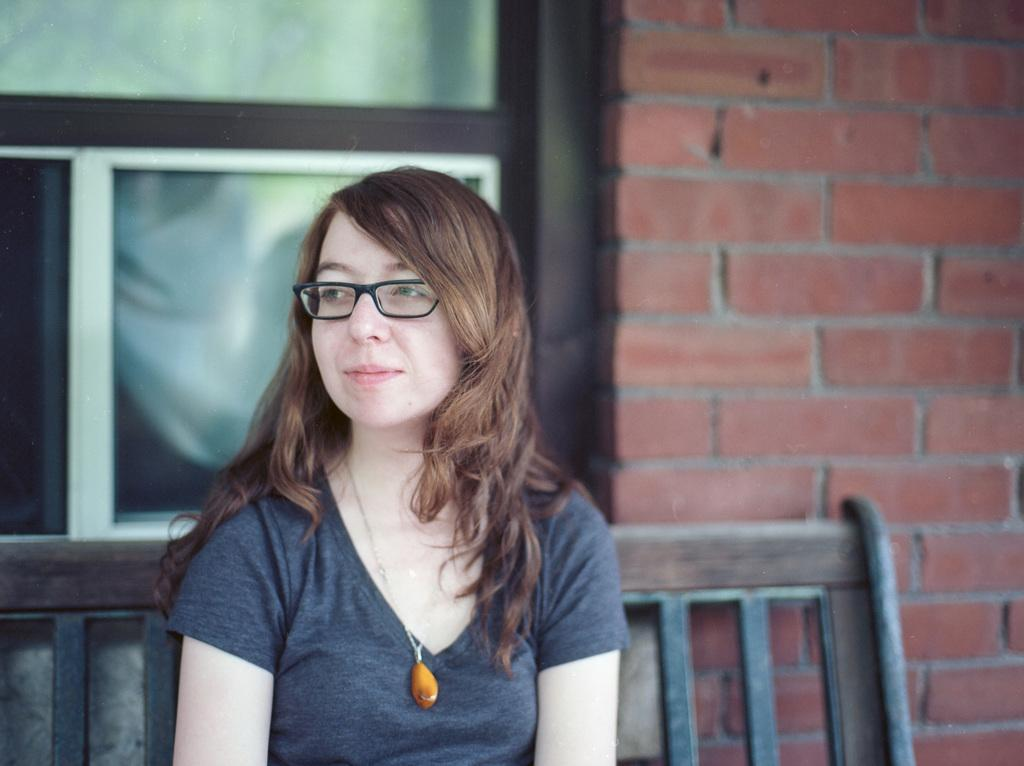What is the woman in the image doing? The woman is sitting on a bench in the image. What expression does the woman have? The woman is smiling. What can be seen in the background of the image? There is a brick wall and a window in the background of the image. What type of current is flowing through the dinosaurs in the image? There are no dinosaurs or currents present in the image. What color is the gold in the image? There is no gold present in the image. 